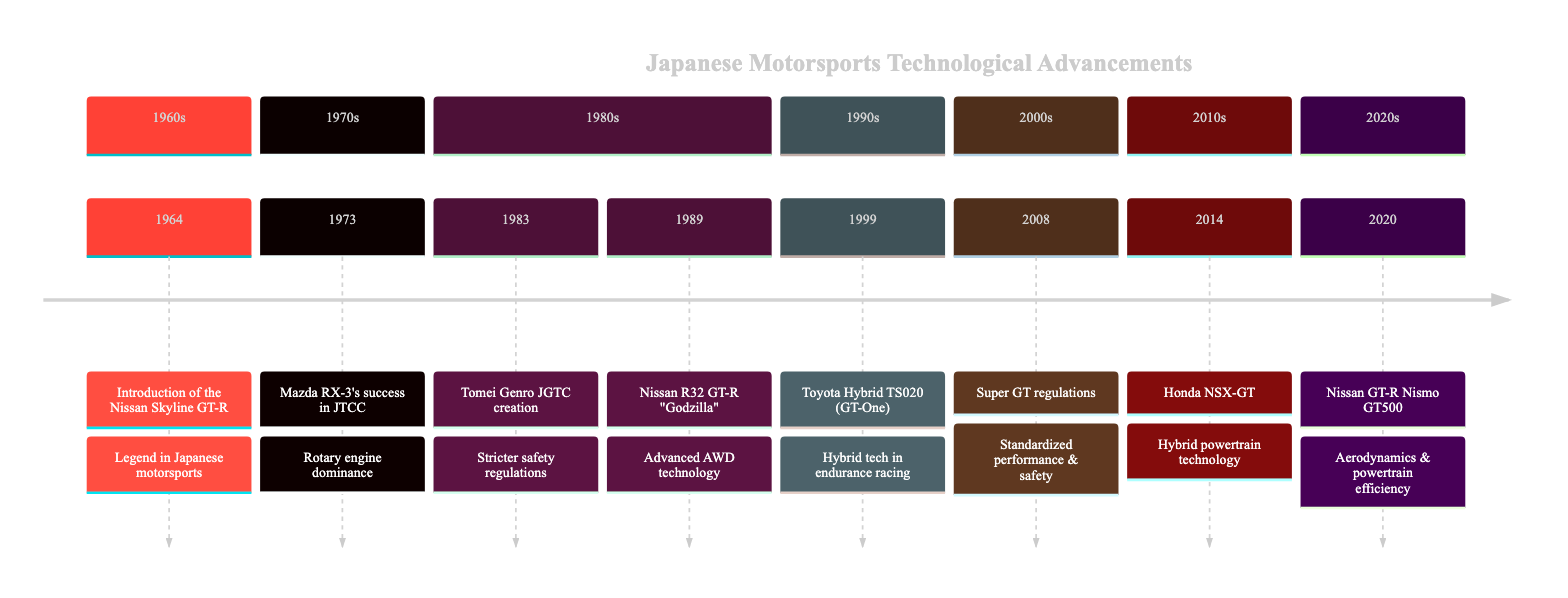What year was the Nissan Skyline GT-R introduced? The diagram lists the introduction of the Nissan Skyline GT-R as occurring in 1964. By locating the event on the timeline, we can find the specific year associated with it.
Answer: 1964 What notable technology did the Nissan R32 GT-R feature? The diagram indicates that the Nissan R32 GT-R is known for its advanced all-wheel-drive technology. This is directly stated in the details provided with the event on the timeline.
Answer: AWD technology What major championship did the Mazda RX-3 dominate in 1973? According to the timeline, the Mazda RX-3's success is highlighted in the Japanese Touring Car Championship (JTCC). It mentions the championship specifically in the event details.
Answer: JTCC In which year did Toyota debut the Hybrid TS020? The timeline clearly states that Toyota introduced the Hybrid TS020 in 1999. By referencing the year associated with this particular event, we identify the debut year.
Answer: 1999 What regulation implementation occurred in 2008? The timeline states the implementation of Super GT regulations in 2008. By looking at the given year and the event, we understand the regulation change noted in the timeline.
Answer: Super GT regulations Which vehicle introduced hybrid powertrain technology in 2014? According to the timeline, the Honda NSX-GT is the vehicle that introduced hybrid powertrain technology in 2014. The event details specify which vehicle made this technological advancement.
Answer: Honda NSX-GT How many significant events are highlighted in the timeline? The timeline lists a total of eight significant events regarding technological advancements in Japanese motorsports vehicles. We can count the events directly from the provided data.
Answer: 8 What was the purpose of creating the Tomei Genro JGTC in 1983? The timeline notes that the creation of the Tomei Genro JGTC brought stricter safety regulations while fostering innovation in vehicle design and technology. This can be deduced from the details of the event listed.
Answer: Stricter safety regulations Which vehicle improved performance due to advancements in aerodynamics in 2020? The timeline indicates that the Nissan GT-R Nismo GT500 excelled in performance due to advancements in aerodynamics and powertrain efficiency. By referencing the 2020 event, we identify the vehicle responsible for these improvements.
Answer: Nissan GT-R Nismo GT500 